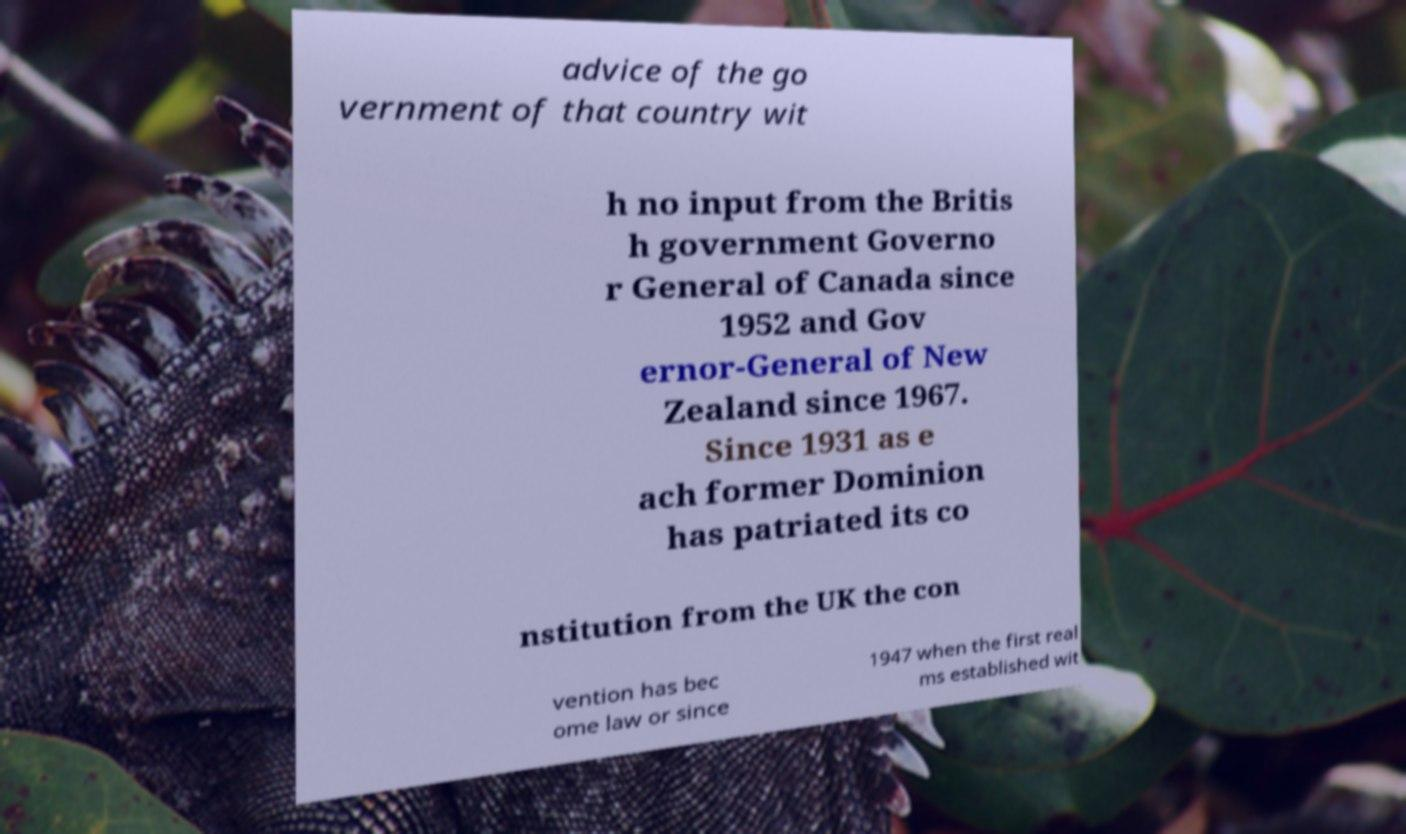For documentation purposes, I need the text within this image transcribed. Could you provide that? advice of the go vernment of that country wit h no input from the Britis h government Governo r General of Canada since 1952 and Gov ernor-General of New Zealand since 1967. Since 1931 as e ach former Dominion has patriated its co nstitution from the UK the con vention has bec ome law or since 1947 when the first real ms established wit 